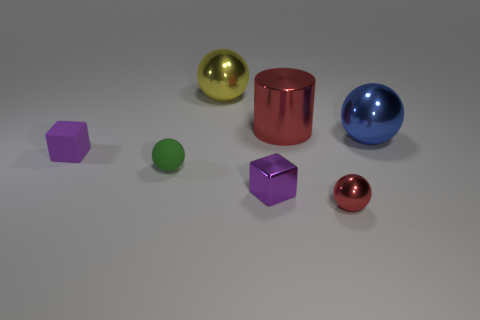Is the material of the small red thing the same as the red cylinder?
Your answer should be very brief. Yes. Are there any purple rubber objects of the same shape as the large red metallic object?
Offer a terse response. No. Do the small ball that is in front of the metal block and the metal cube have the same color?
Ensure brevity in your answer.  No. There is a green matte object that is to the left of the big yellow metal thing; is it the same size as the red metallic object that is in front of the blue metallic object?
Keep it short and to the point. Yes. What size is the block that is made of the same material as the cylinder?
Your response must be concise. Small. What number of balls are both behind the small red sphere and in front of the cylinder?
Your response must be concise. 2. What number of things are either large red metal cylinders or things on the right side of the matte sphere?
Keep it short and to the point. 5. The tiny thing that is the same color as the large cylinder is what shape?
Offer a very short reply. Sphere. There is a big metallic ball on the left side of the blue ball; what is its color?
Make the answer very short. Yellow. How many things are either metal spheres that are in front of the large blue metallic object or small purple matte balls?
Provide a short and direct response. 1. 